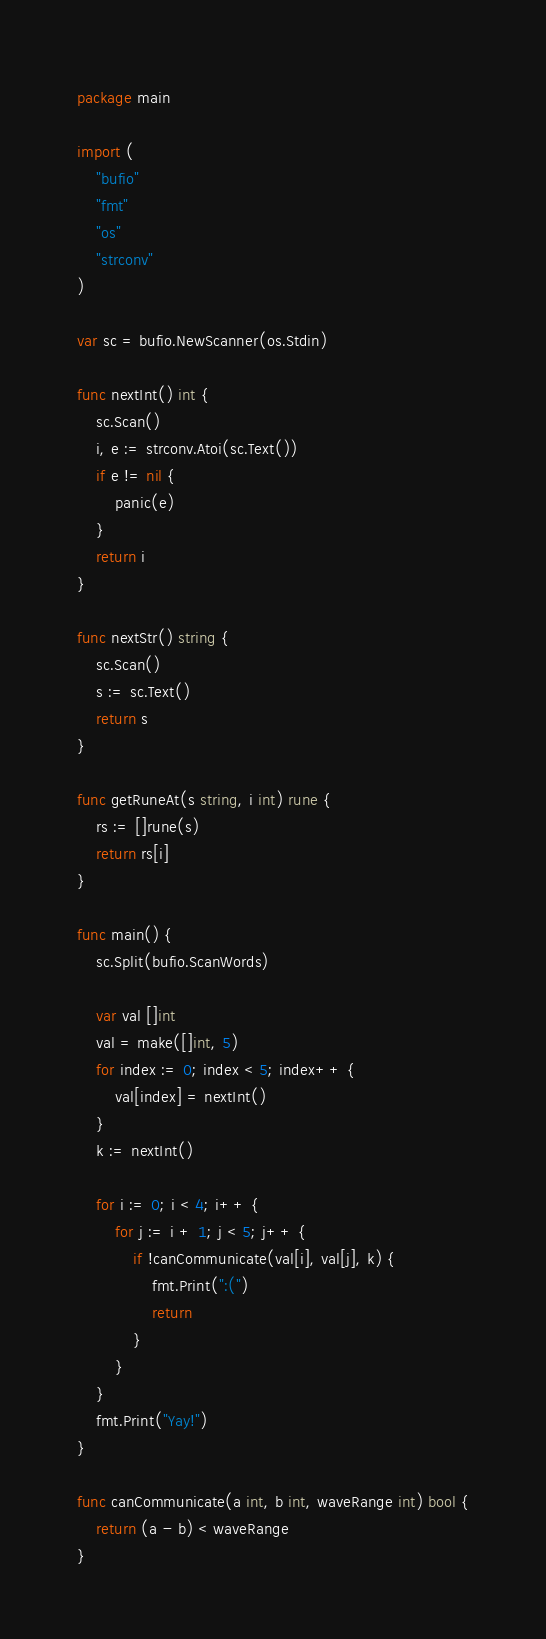Convert code to text. <code><loc_0><loc_0><loc_500><loc_500><_Go_>package main

import (
	"bufio"
	"fmt"
	"os"
	"strconv"
)

var sc = bufio.NewScanner(os.Stdin)

func nextInt() int {
	sc.Scan()
	i, e := strconv.Atoi(sc.Text())
	if e != nil {
		panic(e)
	}
	return i
}

func nextStr() string {
	sc.Scan()
	s := sc.Text()
	return s
}

func getRuneAt(s string, i int) rune {
	rs := []rune(s)
	return rs[i]
}

func main() {
	sc.Split(bufio.ScanWords)

	var val []int
	val = make([]int, 5)
	for index := 0; index < 5; index++ {
		val[index] = nextInt()
	}
	k := nextInt()

	for i := 0; i < 4; i++ {
		for j := i + 1; j < 5; j++ {
			if !canCommunicate(val[i], val[j], k) {
				fmt.Print(":(")
				return
			}
		}
	}
	fmt.Print("Yay!")
}

func canCommunicate(a int, b int, waveRange int) bool {
	return (a - b) < waveRange
}
</code> 